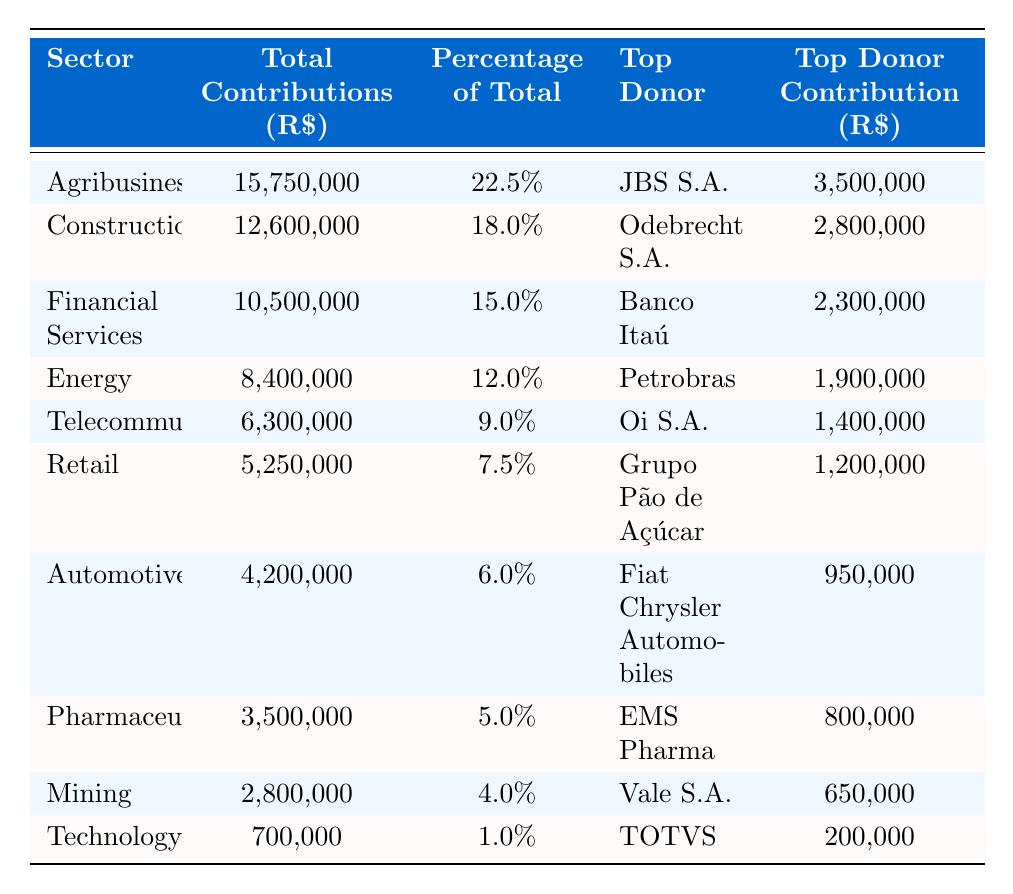What sector received the most contributions? The first row in the table lists Agribusiness with total contributions of R$ 15,750,000, which is the highest value compared to all other sectors.
Answer: Agribusiness What is the contribution percentage of the Financial Services sector? The table shows Financial Services has a percentage of total contributions listed as 15.0%.
Answer: 15.0% Who is the top donor in the Energy sector? The table indicates that Petrobras is the top donor listed under the Energy sector.
Answer: Petrobras How much did JBS S.A. contribute? JBS S.A. is listed as the top donor for the Agribusiness sector with a contribution of R$ 3,500,000.
Answer: R$ 3,500,000 What is the total contribution amount for sectors other than Technology? To find the total contribution for other sectors, we sum the contributions of all sectors except Technology: 15,750,000 + 12,600,000 + 10,500,000 + 8,400,000 + 6,300,000 + 5,250,000 + 4,200,000 + 3,500,000 + 2,800,000 = 69,800,000.
Answer: R$ 69,800,000 What percentage of total contributions comes from the Telecommunications sector? The Telecommunications sector percentage listed in the table is 9.0%.
Answer: 9.0% What is the top donor contribution in the Automotive sector? The Automotive sector lists Fiat Chrysler Automobiles as the top donor with a contribution of R$ 950,000.
Answer: R$ 950,000 Which sector received contributions totaling less than R$ 3 million? The Technology sector, with total contributions of R$ 700,000, stands out as the only sector with less than R$ 3 million.
Answer: Technology What is the combined total contribution of the Mining and Pharmaceuticals sectors? We can sum the contributions of both sectors: Mining at R$ 2,800,000 and Pharmaceuticals at R$ 3,500,000 give us a combined total of R$ 2,800,000 + R$ 3,500,000 = R$ 6,300,000.
Answer: R$ 6,300,000 Is the top donor in the Retail sector greater than R$ 1 million? According to the table, the top donor in the Retail sector is Grupo Pão de Açúcar with a contribution of R$ 1,200,000, which is indeed greater than R$ 1 million.
Answer: Yes How does the contribution of the Agribusiness sector compare to that of the Financial Services sector? Agribusiness contributes R$ 15,750,000, while Financial Services contributes R$ 10,500,000. The difference is R$ 15,750,000 - R$ 10,500,000 = R$ 5,250,000, indicating Agribusiness contributed R$ 5,250,000 more.
Answer: R$ 5,250,000 more 